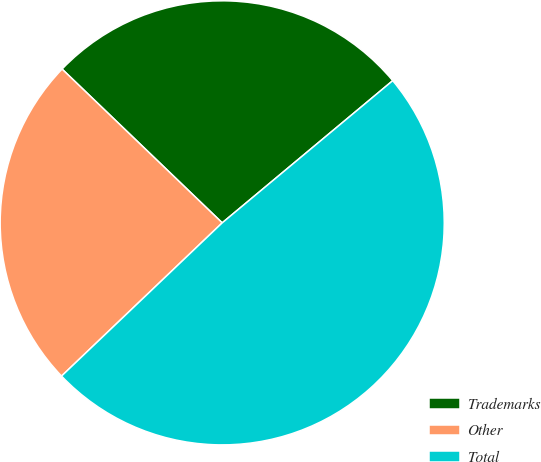Convert chart. <chart><loc_0><loc_0><loc_500><loc_500><pie_chart><fcel>Trademarks<fcel>Other<fcel>Total<nl><fcel>26.76%<fcel>24.3%<fcel>48.94%<nl></chart> 